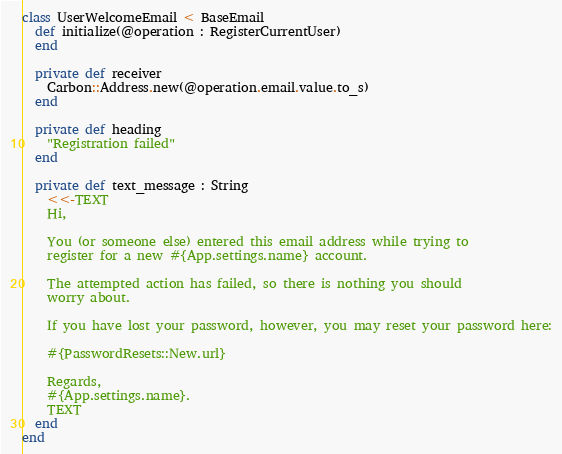<code> <loc_0><loc_0><loc_500><loc_500><_Crystal_>class UserWelcomeEmail < BaseEmail
  def initialize(@operation : RegisterCurrentUser)
  end

  private def receiver
    Carbon::Address.new(@operation.email.value.to_s)
  end

  private def heading
    "Registration failed"
  end

  private def text_message : String
    <<-TEXT
    Hi,

    You (or someone else) entered this email address while trying to
    register for a new #{App.settings.name} account.

    The attempted action has failed, so there is nothing you should
    worry about.

    If you have lost your password, however, you may reset your password here:

    #{PasswordResets::New.url}

    Regards,
    #{App.settings.name}.
    TEXT
  end
end
</code> 